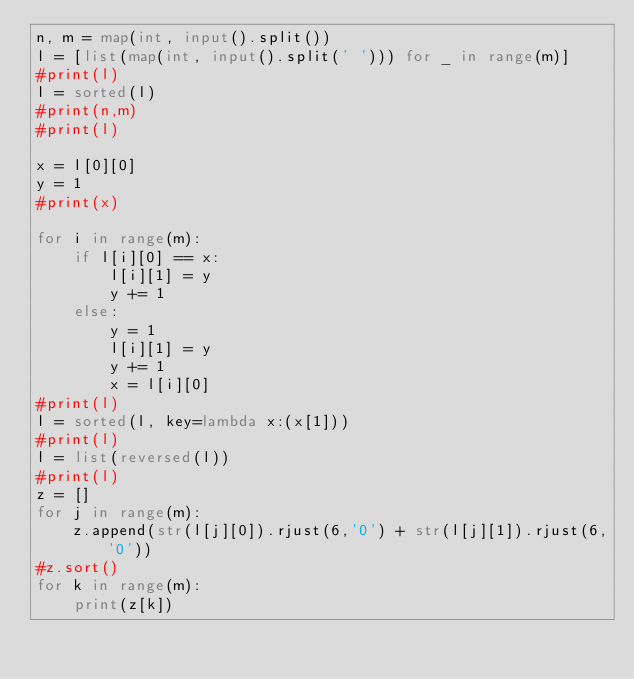Convert code to text. <code><loc_0><loc_0><loc_500><loc_500><_Python_>n, m = map(int, input().split())
l = [list(map(int, input().split(' '))) for _ in range(m)]
#print(l)
l = sorted(l)
#print(n,m)
#print(l)

x = l[0][0]
y = 1
#print(x)

for i in range(m):
    if l[i][0] == x:
        l[i][1] = y
        y += 1
    else:
        y = 1
        l[i][1] = y
        y += 1
        x = l[i][0]
#print(l)
l = sorted(l, key=lambda x:(x[1]))
#print(l)
l = list(reversed(l))
#print(l)
z = []
for j in range(m):
    z.append(str(l[j][0]).rjust(6,'0') + str(l[j][1]).rjust(6,'0'))
#z.sort()
for k in range(m):
    print(z[k])</code> 